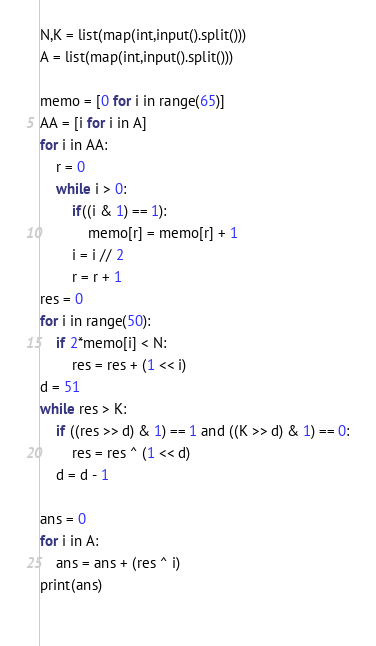Convert code to text. <code><loc_0><loc_0><loc_500><loc_500><_Python_>N,K = list(map(int,input().split()))
A = list(map(int,input().split()))

memo = [0 for i in range(65)]
AA = [i for i in A]
for i in AA:
	r = 0
	while i > 0:
		if((i & 1) == 1):
			memo[r] = memo[r] + 1
		i = i // 2
		r = r + 1
res = 0
for i in range(50):
	if 2*memo[i] < N:
		res = res + (1 << i)
d = 51
while res > K:
	if ((res >> d) & 1) == 1 and ((K >> d) & 1) == 0:
		res = res ^ (1 << d)
	d = d - 1
    
ans = 0
for i in A:
	ans = ans + (res ^ i)
print(ans)
  </code> 